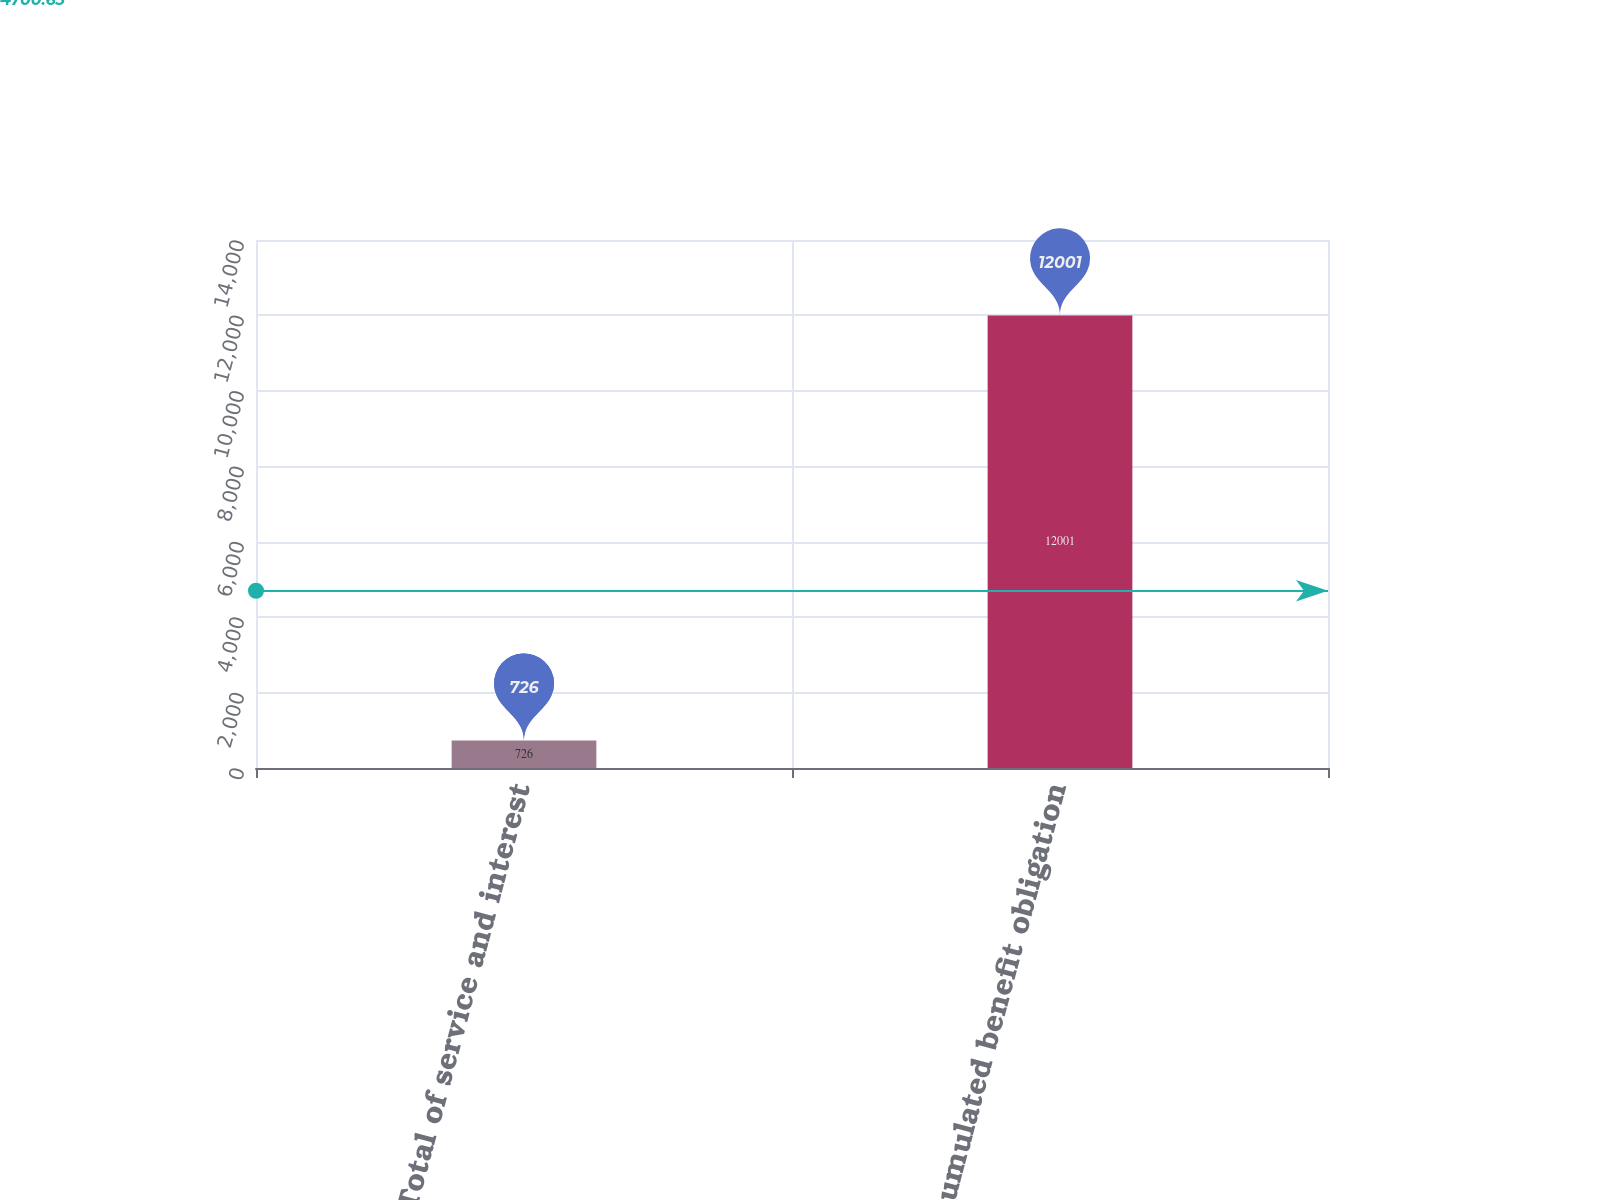Convert chart to OTSL. <chart><loc_0><loc_0><loc_500><loc_500><bar_chart><fcel>Total of service and interest<fcel>Accumulated benefit obligation<nl><fcel>726<fcel>12001<nl></chart> 